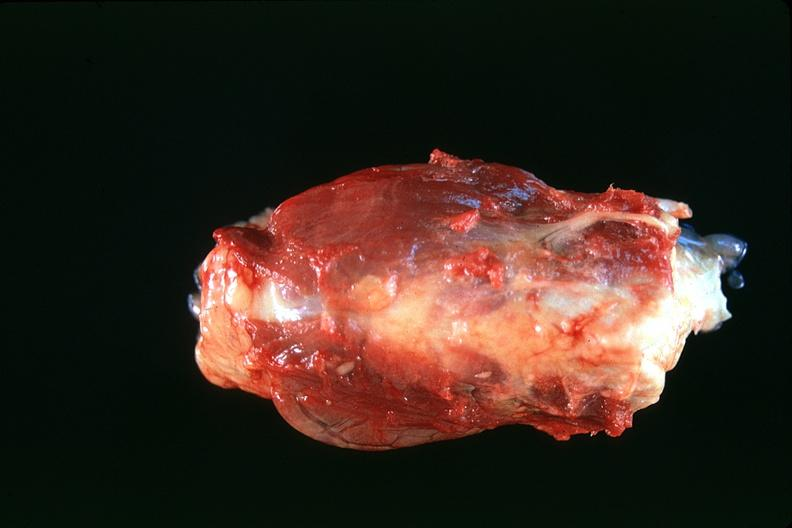where does this belong to?
Answer the question using a single word or phrase. Endocrine system 